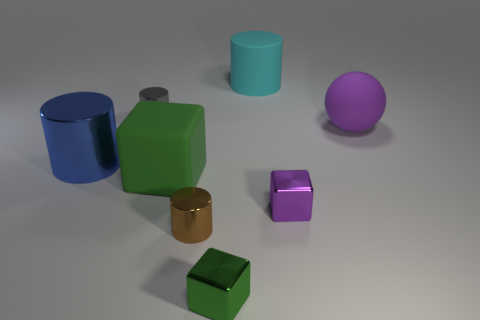Add 1 big metallic objects. How many objects exist? 9 Subtract all cubes. How many objects are left? 5 Add 8 tiny purple metallic cubes. How many tiny purple metallic cubes exist? 9 Subtract 0 red cylinders. How many objects are left? 8 Subtract all blue shiny objects. Subtract all large red metallic blocks. How many objects are left? 7 Add 6 small green cubes. How many small green cubes are left? 7 